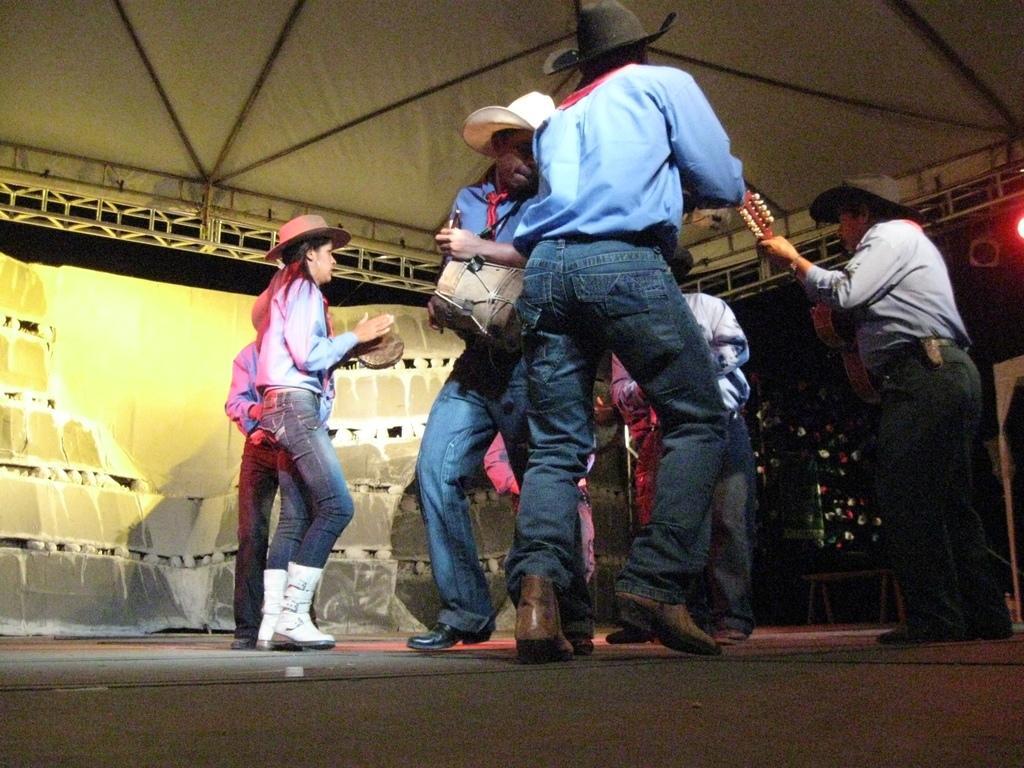Describe this image in one or two sentences. In the image there are people in cowboy dress and hat,boots dancing on the stage and there are lights over the ceiling. 